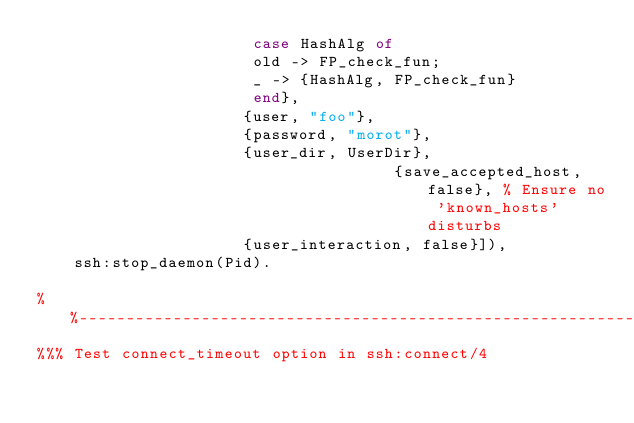Convert code to text. <code><loc_0><loc_0><loc_500><loc_500><_Erlang_>				       case HashAlg of
					   old -> FP_check_fun;
					   _ -> {HashAlg, FP_check_fun}
				       end},
				      {user, "foo"},
				      {password, "morot"},
				      {user_dir, UserDir},
                                      {save_accepted_host, false}, % Ensure no 'known_hosts' disturbs
				      {user_interaction, false}]),
    ssh:stop_daemon(Pid).

%%--------------------------------------------------------------------
%%% Test connect_timeout option in ssh:connect/4</code> 